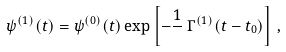Convert formula to latex. <formula><loc_0><loc_0><loc_500><loc_500>\psi ^ { ( 1 ) } ( t ) = \psi ^ { ( 0 ) } ( t ) \exp \left [ - \frac { 1 } { } \, \Gamma ^ { ( 1 ) } ( t - t _ { 0 } ) \right ] \, ,</formula> 